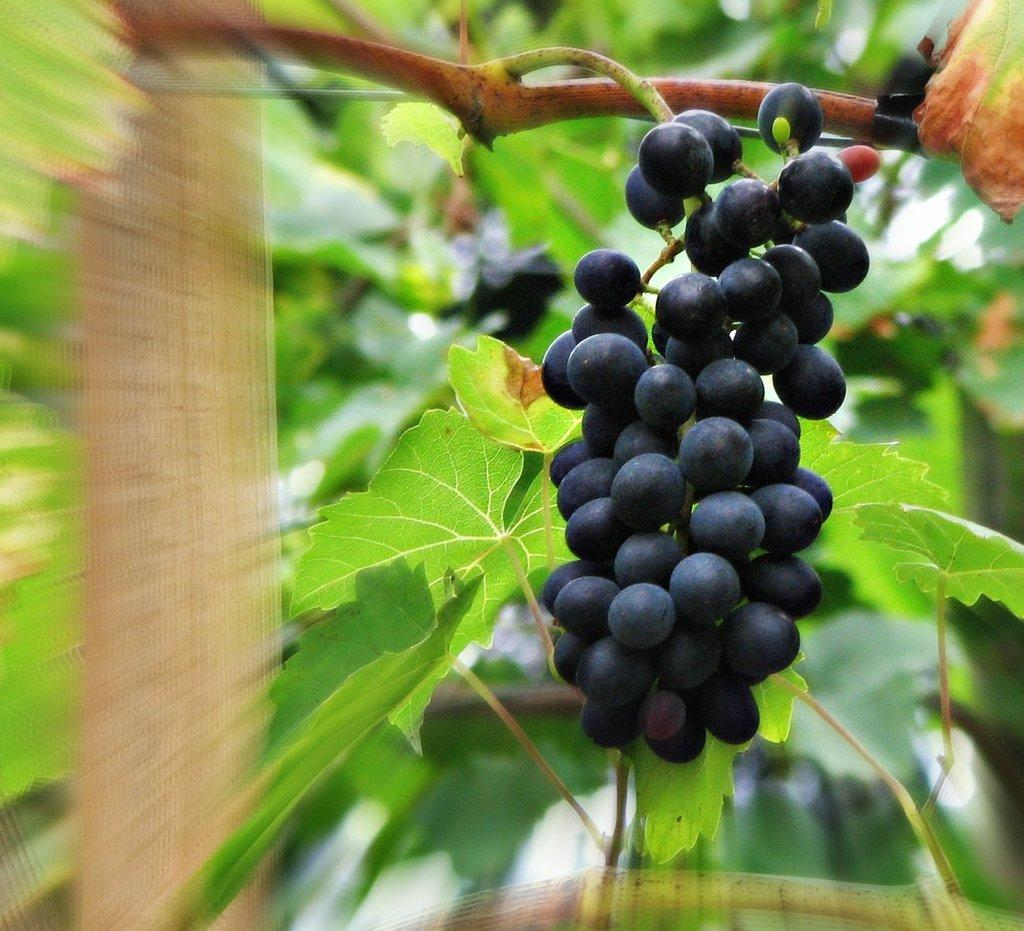What type of plant is present in the image? There is a plant of grapes in the image. What color are the grapes on the plant? The grapes are black in color. On which side of the image are the grapes located? The grapes are on the right side of the image. Can you see a hydrant in the image? There is no hydrant present in the image. Is there a giraffe eating the grapes in the image? There is no giraffe present in the image, and therefore it cannot be eating the grapes. 